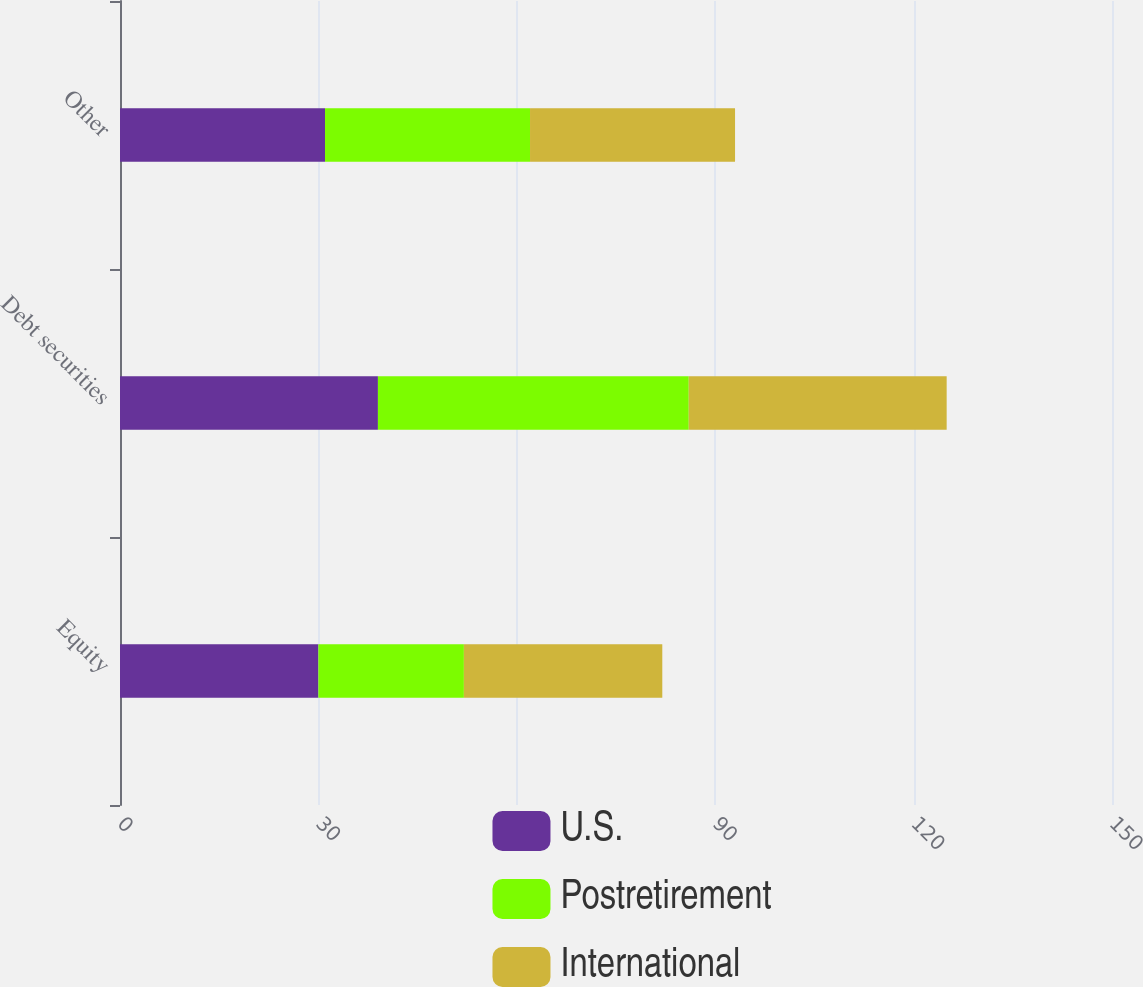Convert chart to OTSL. <chart><loc_0><loc_0><loc_500><loc_500><stacked_bar_chart><ecel><fcel>Equity<fcel>Debt securities<fcel>Other<nl><fcel>U.S.<fcel>30<fcel>39<fcel>31<nl><fcel>Postretirement<fcel>22<fcel>47<fcel>31<nl><fcel>International<fcel>30<fcel>39<fcel>31<nl></chart> 